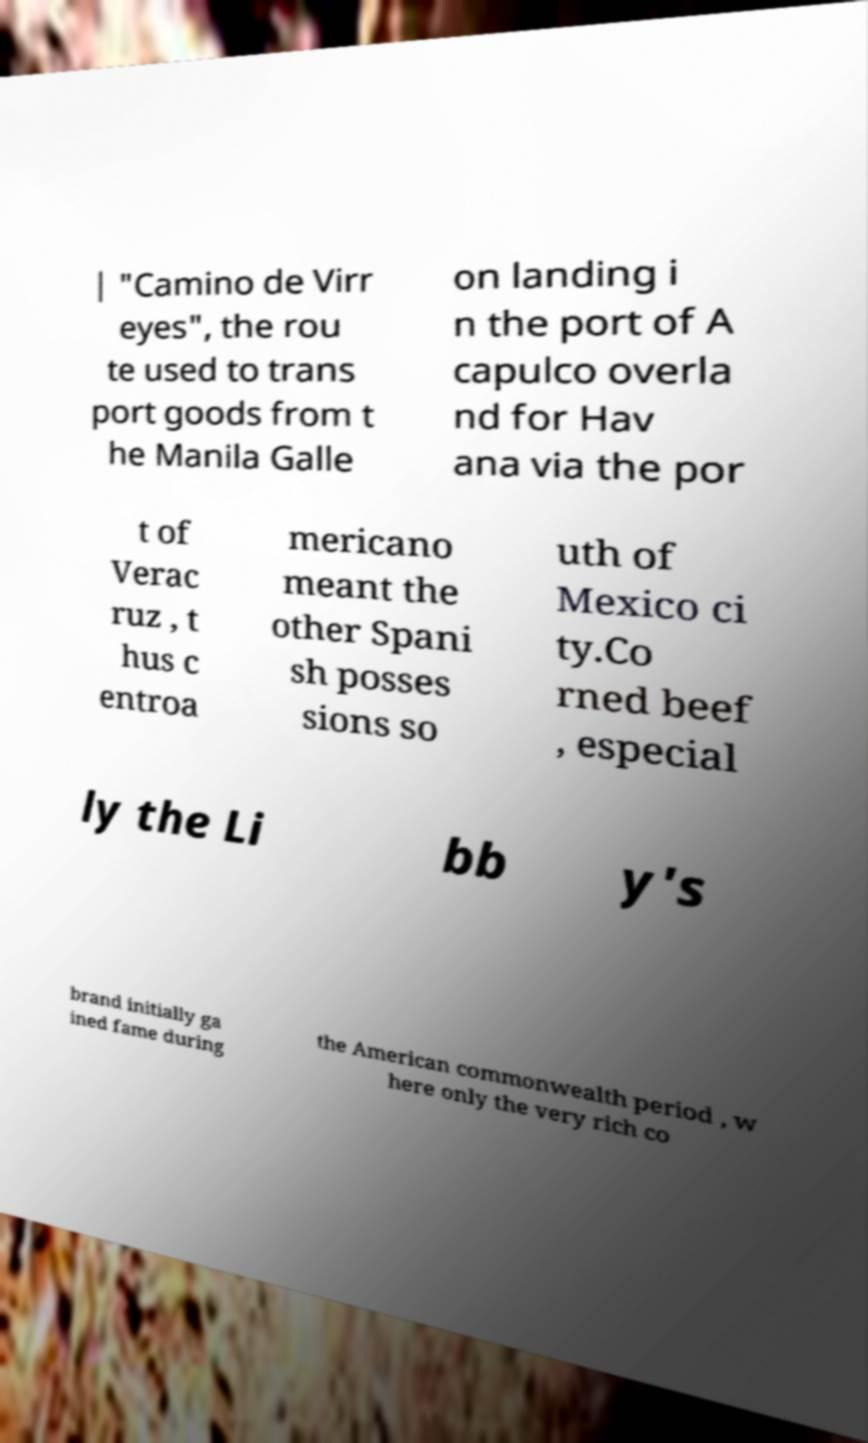There's text embedded in this image that I need extracted. Can you transcribe it verbatim? | "Camino de Virr eyes", the rou te used to trans port goods from t he Manila Galle on landing i n the port of A capulco overla nd for Hav ana via the por t of Verac ruz , t hus c entroa mericano meant the other Spani sh posses sions so uth of Mexico ci ty.Co rned beef , especial ly the Li bb y's brand initially ga ined fame during the American commonwealth period , w here only the very rich co 